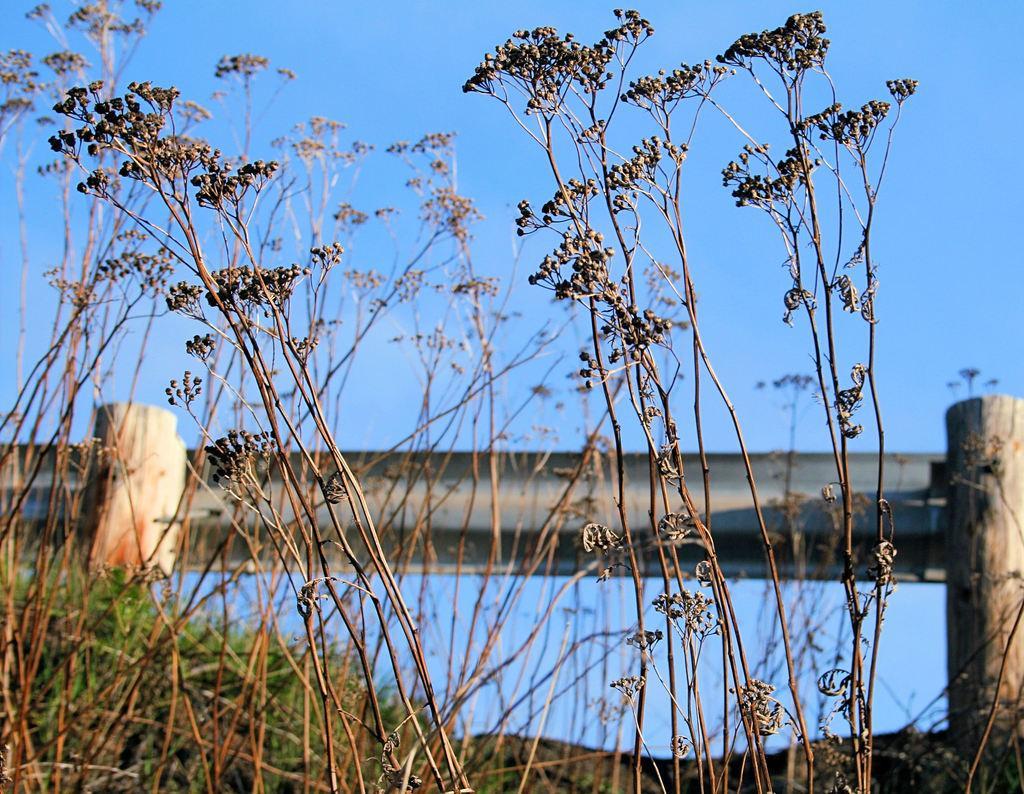How would you summarize this image in a sentence or two? In the foreground of the picture there are plants. In the center of the picture there are grass and railing. Sky is sunny. 